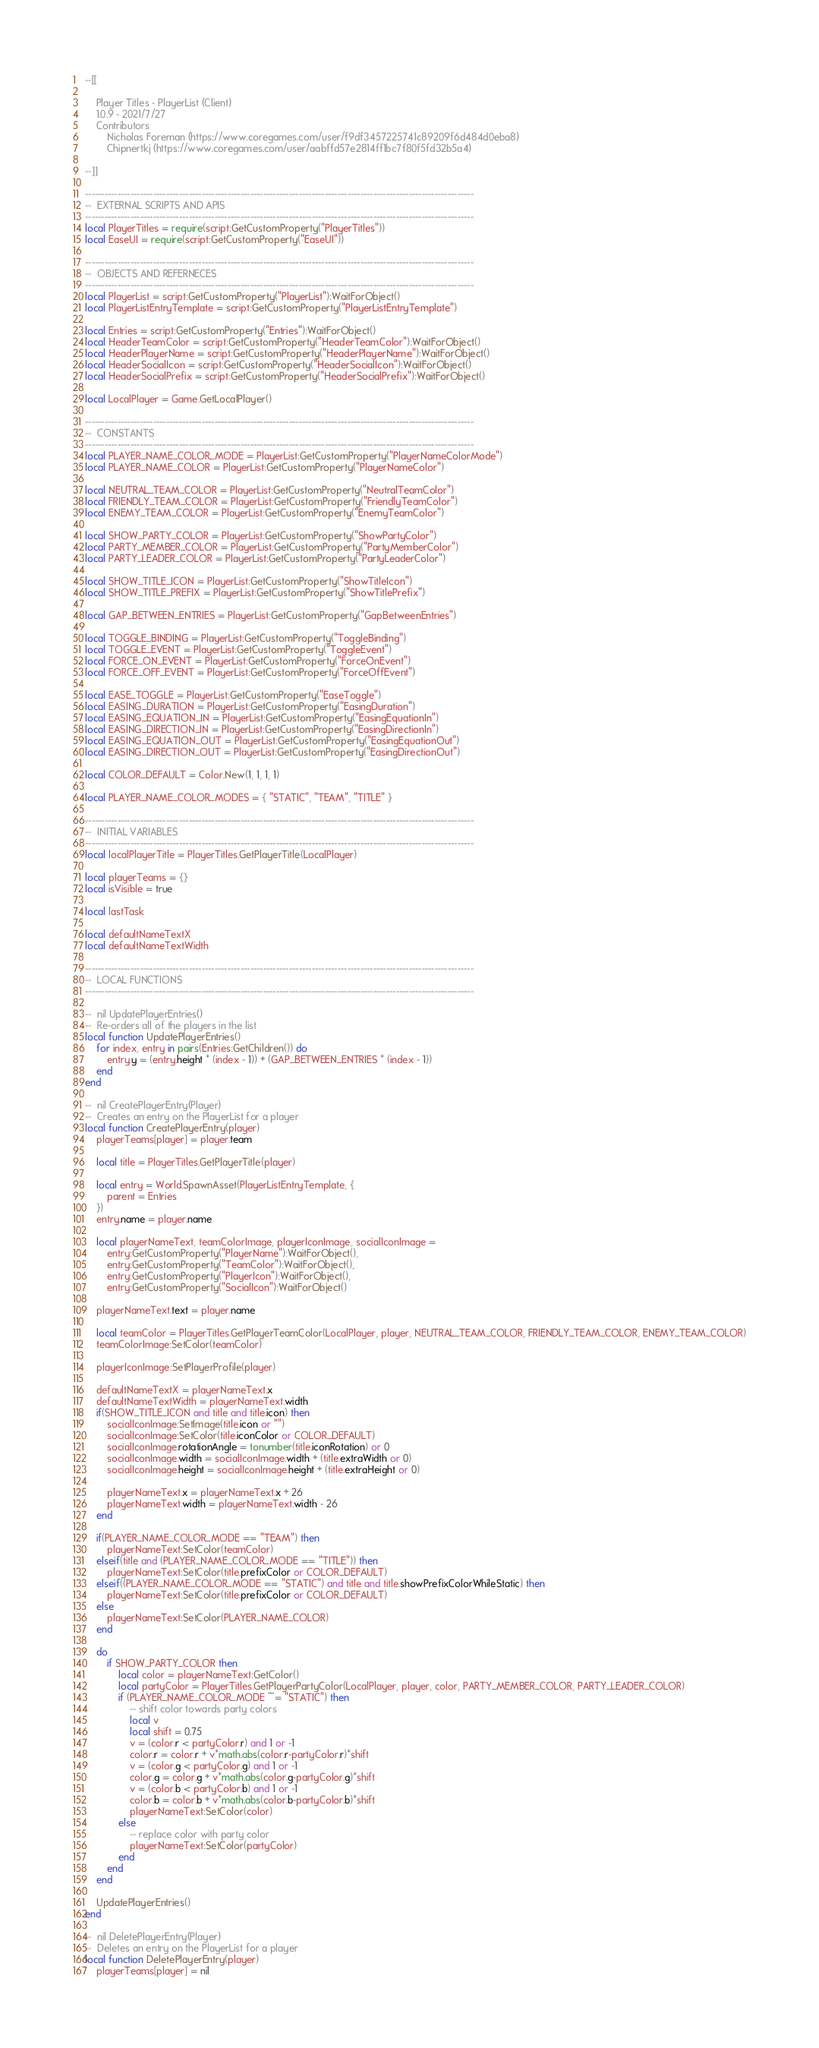<code> <loc_0><loc_0><loc_500><loc_500><_Lua_>--[[

	Player Titles - PlayerList (Client)
	1.0.9 - 2021/7/27
	Contributors
		Nicholas Foreman (https://www.coregames.com/user/f9df3457225741c89209f6d484d0eba8)
		Chipnertkj (https://www.coregames.com/user/aabffd57e2814ff1bc7f80f5fd32b5a4)

--]]

------------------------------------------------------------------------------------------------------------------------
--	EXTERNAL SCRIPTS AND APIS
------------------------------------------------------------------------------------------------------------------------
local PlayerTitles = require(script:GetCustomProperty("PlayerTitles"))
local EaseUI = require(script:GetCustomProperty("EaseUI"))

------------------------------------------------------------------------------------------------------------------------
--	OBJECTS AND REFERNECES
------------------------------------------------------------------------------------------------------------------------
local PlayerList = script:GetCustomProperty("PlayerList"):WaitForObject()
local PlayerListEntryTemplate = script:GetCustomProperty("PlayerListEntryTemplate")

local Entries = script:GetCustomProperty("Entries"):WaitForObject()
local HeaderTeamColor = script:GetCustomProperty("HeaderTeamColor"):WaitForObject()
local HeaderPlayerName = script:GetCustomProperty("HeaderPlayerName"):WaitForObject()
local HeaderSocialIcon = script:GetCustomProperty("HeaderSocialIcon"):WaitForObject()
local HeaderSocialPrefix = script:GetCustomProperty("HeaderSocialPrefix"):WaitForObject()

local LocalPlayer = Game.GetLocalPlayer()

------------------------------------------------------------------------------------------------------------------------
--	CONSTANTS
------------------------------------------------------------------------------------------------------------------------
local PLAYER_NAME_COLOR_MODE = PlayerList:GetCustomProperty("PlayerNameColorMode")
local PLAYER_NAME_COLOR = PlayerList:GetCustomProperty("PlayerNameColor")

local NEUTRAL_TEAM_COLOR = PlayerList:GetCustomProperty("NeutralTeamColor")
local FRIENDLY_TEAM_COLOR = PlayerList:GetCustomProperty("FriendlyTeamColor")
local ENEMY_TEAM_COLOR = PlayerList:GetCustomProperty("EnemyTeamColor")

local SHOW_PARTY_COLOR = PlayerList:GetCustomProperty("ShowPartyColor")
local PARTY_MEMBER_COLOR = PlayerList:GetCustomProperty("PartyMemberColor")
local PARTY_LEADER_COLOR = PlayerList:GetCustomProperty("PartyLeaderColor")

local SHOW_TITLE_ICON = PlayerList:GetCustomProperty("ShowTitleIcon")
local SHOW_TITLE_PREFIX = PlayerList:GetCustomProperty("ShowTitlePrefix")

local GAP_BETWEEN_ENTRIES = PlayerList:GetCustomProperty("GapBetweenEntries")

local TOGGLE_BINDING = PlayerList:GetCustomProperty("ToggleBinding")
local TOGGLE_EVENT = PlayerList:GetCustomProperty("ToggleEvent")
local FORCE_ON_EVENT = PlayerList:GetCustomProperty("ForceOnEvent")
local FORCE_OFF_EVENT = PlayerList:GetCustomProperty("ForceOffEvent")

local EASE_TOGGLE = PlayerList:GetCustomProperty("EaseToggle")
local EASING_DURATION = PlayerList:GetCustomProperty("EasingDuration")
local EASING_EQUATION_IN = PlayerList:GetCustomProperty("EasingEquationIn")
local EASING_DIRECTION_IN = PlayerList:GetCustomProperty("EasingDirectionIn")
local EASING_EQUATION_OUT = PlayerList:GetCustomProperty("EasingEquationOut")
local EASING_DIRECTION_OUT = PlayerList:GetCustomProperty("EasingDirectionOut")

local COLOR_DEFAULT = Color.New(1, 1, 1, 1)

local PLAYER_NAME_COLOR_MODES = { "STATIC", "TEAM", "TITLE" }

------------------------------------------------------------------------------------------------------------------------
--	INITIAL VARIABLES
------------------------------------------------------------------------------------------------------------------------
local localPlayerTitle = PlayerTitles.GetPlayerTitle(LocalPlayer)

local playerTeams = {}
local isVisible = true

local lastTask

local defaultNameTextX
local defaultNameTextWidth

------------------------------------------------------------------------------------------------------------------------
--	LOCAL FUNCTIONS
------------------------------------------------------------------------------------------------------------------------

--	nil UpdatePlayerEntries()
--	Re-orders all of the players in the list
local function UpdatePlayerEntries()
	for index, entry in pairs(Entries:GetChildren()) do
		entry.y = (entry.height * (index - 1)) + (GAP_BETWEEN_ENTRIES * (index - 1))
	end
end

--	nil CreatePlayerEntry(Player)
--	Creates an entry on the PlayerList for a player
local function CreatePlayerEntry(player)
	playerTeams[player] = player.team

	local title = PlayerTitles.GetPlayerTitle(player)

	local entry = World.SpawnAsset(PlayerListEntryTemplate, {
		parent = Entries
	})
	entry.name = player.name

	local playerNameText, teamColorImage, playerIconImage, socialIconImage =
		entry:GetCustomProperty("PlayerName"):WaitForObject(),
		entry:GetCustomProperty("TeamColor"):WaitForObject(),
		entry:GetCustomProperty("PlayerIcon"):WaitForObject(),
		entry:GetCustomProperty("SocialIcon"):WaitForObject()

	playerNameText.text = player.name

	local teamColor = PlayerTitles.GetPlayerTeamColor(LocalPlayer, player, NEUTRAL_TEAM_COLOR, FRIENDLY_TEAM_COLOR, ENEMY_TEAM_COLOR)
	teamColorImage:SetColor(teamColor)

	playerIconImage:SetPlayerProfile(player)

	defaultNameTextX = playerNameText.x
	defaultNameTextWidth = playerNameText.width
	if(SHOW_TITLE_ICON and title and title.icon) then
		socialIconImage:SetImage(title.icon or "")
		socialIconImage:SetColor(title.iconColor or COLOR_DEFAULT)
		socialIconImage.rotationAngle = tonumber(title.iconRotation) or 0
		socialIconImage.width = socialIconImage.width + (title.extraWidth or 0)
		socialIconImage.height = socialIconImage.height + (title.extraHeight or 0)

		playerNameText.x = playerNameText.x + 26
		playerNameText.width = playerNameText.width - 26
	end

	if(PLAYER_NAME_COLOR_MODE == "TEAM") then
		playerNameText:SetColor(teamColor)
	elseif(title and (PLAYER_NAME_COLOR_MODE == "TITLE")) then
		playerNameText:SetColor(title.prefixColor or COLOR_DEFAULT)
	elseif((PLAYER_NAME_COLOR_MODE == "STATIC") and title and title.showPrefixColorWhileStatic) then
		playerNameText:SetColor(title.prefixColor or COLOR_DEFAULT)
	else
		playerNameText:SetColor(PLAYER_NAME_COLOR)
	end

	do
		if SHOW_PARTY_COLOR then
			local color = playerNameText:GetColor()
			local partyColor = PlayerTitles.GetPlayerPartyColor(LocalPlayer, player, color, PARTY_MEMBER_COLOR, PARTY_LEADER_COLOR)
			if (PLAYER_NAME_COLOR_MODE ~= "STATIC") then
				-- shift color towards party colors
				local v
				local shift = 0.75
				v = (color.r < partyColor.r) and 1 or -1
				color.r = color.r + v*math.abs(color.r-partyColor.r)*shift
				v = (color.g < partyColor.g) and 1 or -1
				color.g = color.g + v*math.abs(color.g-partyColor.g)*shift
				v = (color.b < partyColor.b) and 1 or -1
				color.b = color.b + v*math.abs(color.b-partyColor.b)*shift
				playerNameText:SetColor(color)
			else
				-- replace color with party color
				playerNameText:SetColor(partyColor)
			end
		end
	end

	UpdatePlayerEntries()
end

--	nil DeletePlayerEntry(Player)
--	Deletes an entry on the PlayerList for a player
local function DeletePlayerEntry(player)
	playerTeams[player] = nil
</code> 